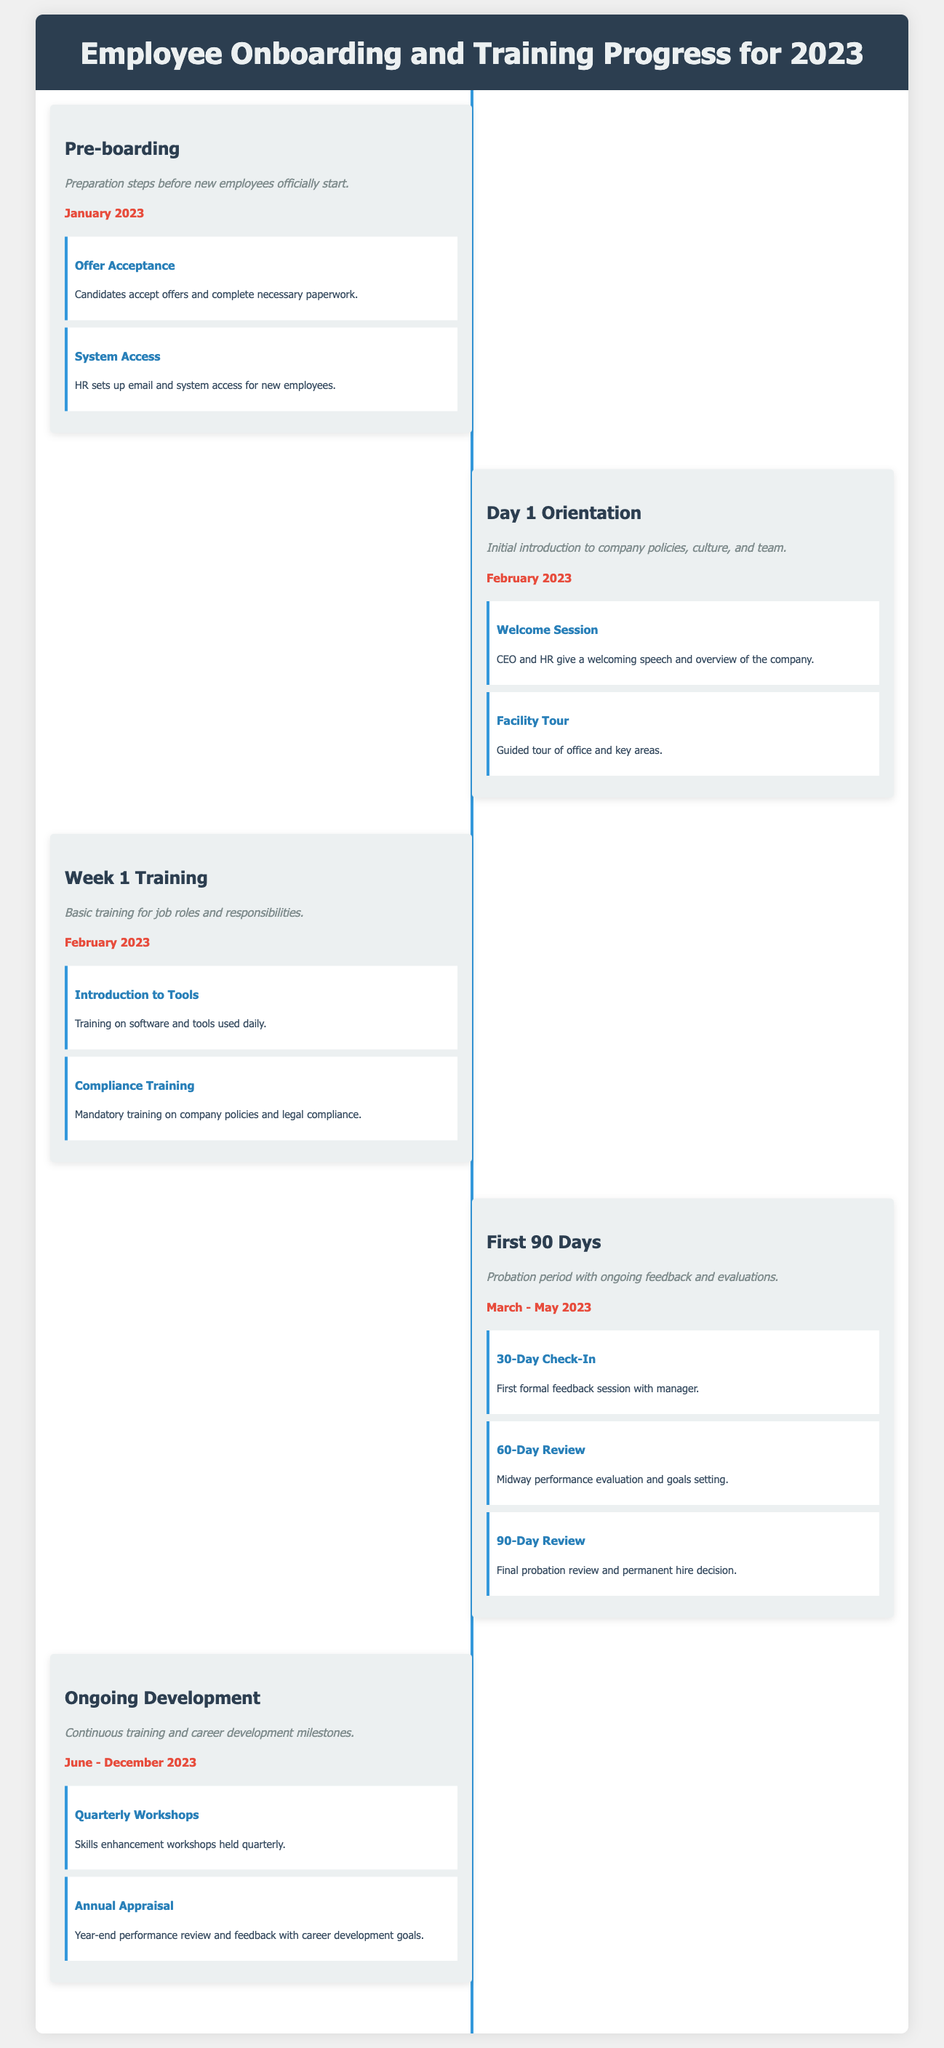What is the title of the infographic? The title of the infographic is prominently displayed at the top, indicating the subject matter.
Answer: Employee Onboarding and Training Progress for 2023 When does the Pre-boarding phase start? The document specifies the starting date for the Pre-boarding phase under that section.
Answer: January 2023 How many milestones are included in the First 90 Days? The number of milestones can be counted in the First 90 Days section of the timeline.
Answer: 3 What activity occurs during the Week 1 Training? The document outlines specific training activities that take place during this phase.
Answer: Introduction to Tools What is the purpose of the Ongoing Development phase? The description given indicates the main focus during the Ongoing Development phase of training.
Answer: Continuous training and career development milestones Which session marks the beginning of the Day 1 Orientation? The first milestone in the Day 1 Orientation section provides details about this introductory session.
Answer: Welcome Session What type of feedback occurs during the 30-Day Check-In? The document describes the nature of the feedback given at this point in time.
Answer: Formal feedback session In which month does the Annual Appraisal take place? The timing of this appraisal can be found in the Ongoing Development phase timeline.
Answer: December 2023 